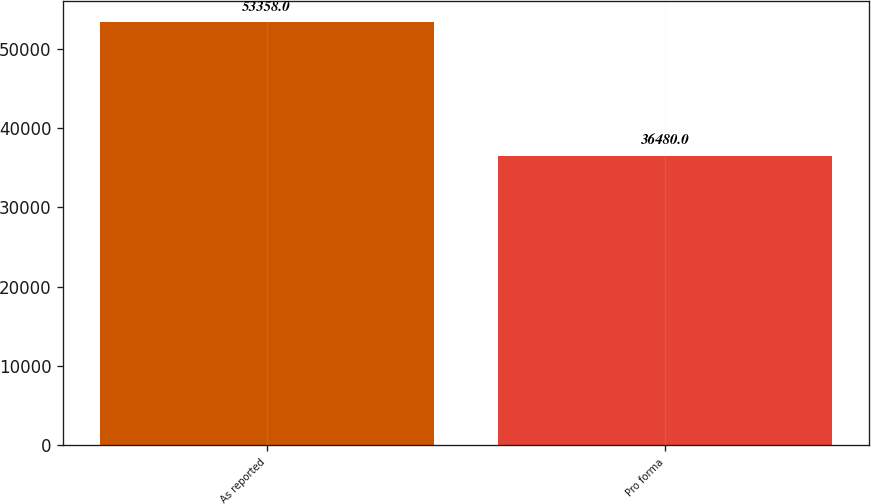Convert chart. <chart><loc_0><loc_0><loc_500><loc_500><bar_chart><fcel>As reported<fcel>Pro forma<nl><fcel>53358<fcel>36480<nl></chart> 